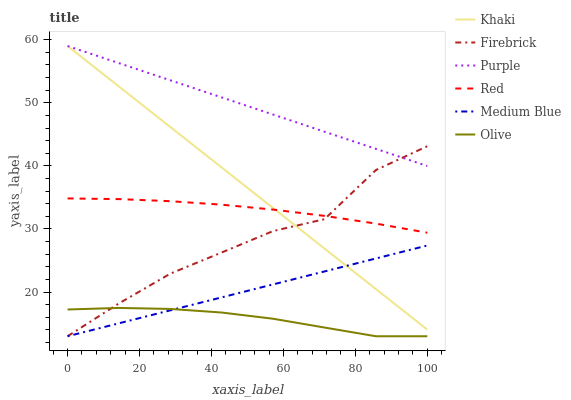Does Olive have the minimum area under the curve?
Answer yes or no. Yes. Does Purple have the maximum area under the curve?
Answer yes or no. Yes. Does Firebrick have the minimum area under the curve?
Answer yes or no. No. Does Firebrick have the maximum area under the curve?
Answer yes or no. No. Is Purple the smoothest?
Answer yes or no. Yes. Is Firebrick the roughest?
Answer yes or no. Yes. Is Firebrick the smoothest?
Answer yes or no. No. Is Purple the roughest?
Answer yes or no. No. Does Firebrick have the lowest value?
Answer yes or no. Yes. Does Purple have the lowest value?
Answer yes or no. No. Does Purple have the highest value?
Answer yes or no. Yes. Does Firebrick have the highest value?
Answer yes or no. No. Is Medium Blue less than Purple?
Answer yes or no. Yes. Is Red greater than Olive?
Answer yes or no. Yes. Does Purple intersect Firebrick?
Answer yes or no. Yes. Is Purple less than Firebrick?
Answer yes or no. No. Is Purple greater than Firebrick?
Answer yes or no. No. Does Medium Blue intersect Purple?
Answer yes or no. No. 